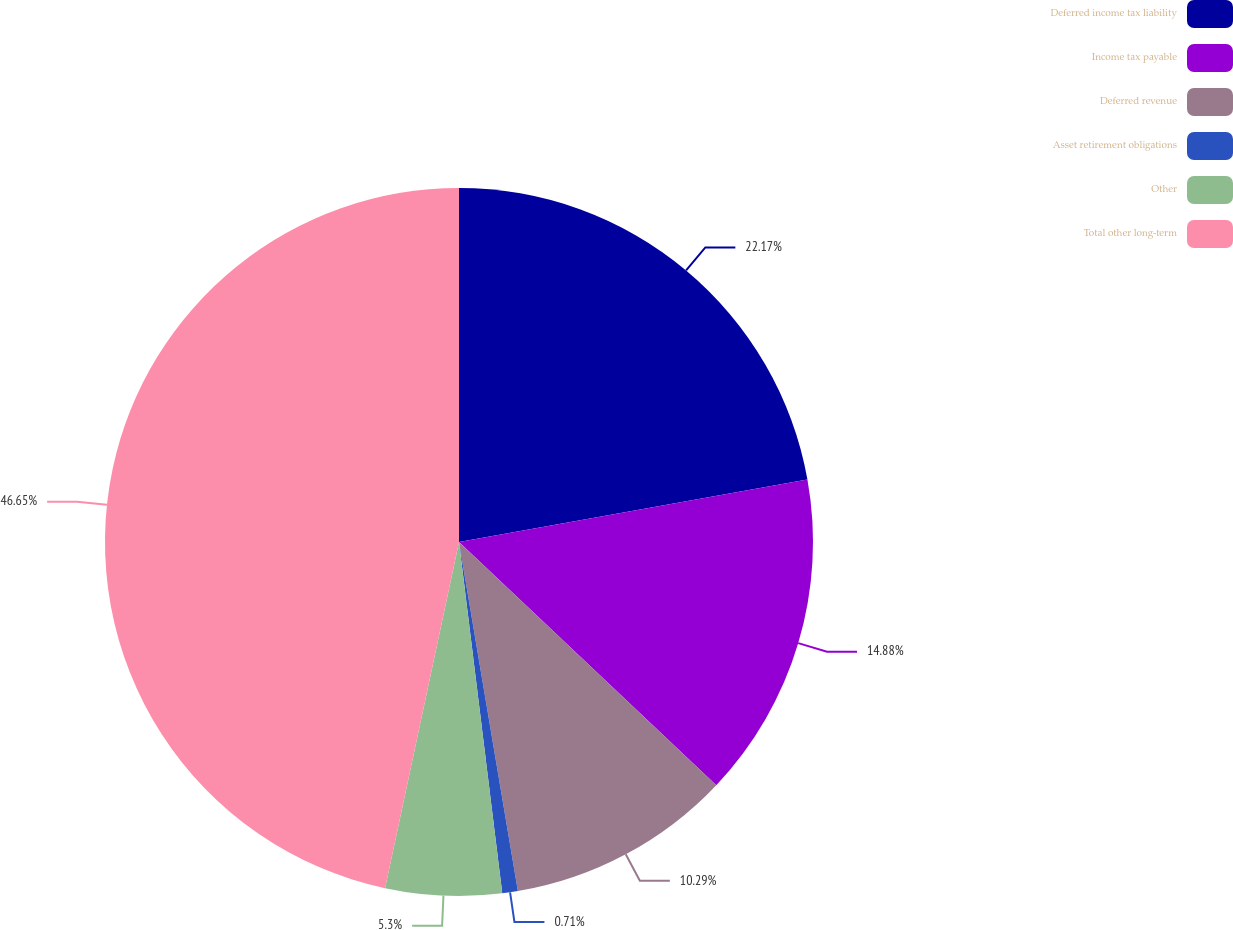Convert chart. <chart><loc_0><loc_0><loc_500><loc_500><pie_chart><fcel>Deferred income tax liability<fcel>Income tax payable<fcel>Deferred revenue<fcel>Asset retirement obligations<fcel>Other<fcel>Total other long-term<nl><fcel>22.17%<fcel>14.88%<fcel>10.29%<fcel>0.71%<fcel>5.3%<fcel>46.65%<nl></chart> 